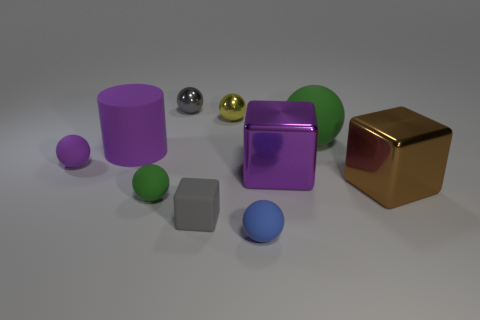Subtract all purple matte spheres. How many spheres are left? 5 Subtract all purple spheres. How many spheres are left? 5 Subtract all red spheres. Subtract all gray cubes. How many spheres are left? 6 Subtract all cubes. How many objects are left? 7 Subtract all large purple matte cylinders. Subtract all big cylinders. How many objects are left? 8 Add 6 big brown shiny blocks. How many big brown shiny blocks are left? 7 Add 3 matte cylinders. How many matte cylinders exist? 4 Subtract 0 red blocks. How many objects are left? 10 